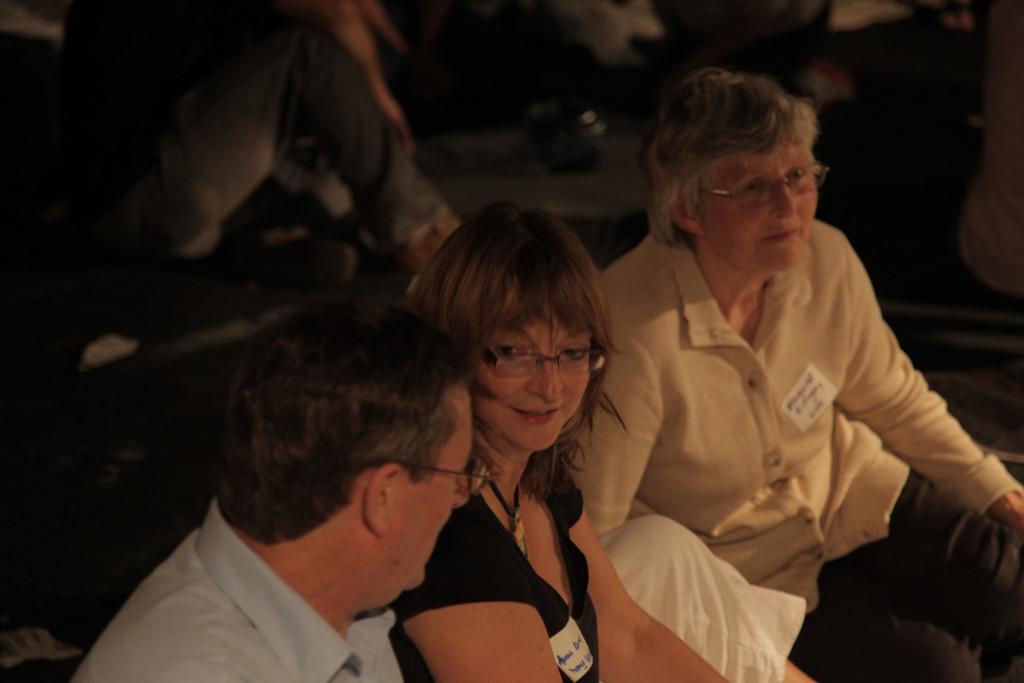How would you summarize this image in a sentence or two? In this image there are three persons sitting on the floor. In the middle there is a woman talking with the man who is beside her. In the background there are few other people sitting on the floor. There is a badge on their shirt. 